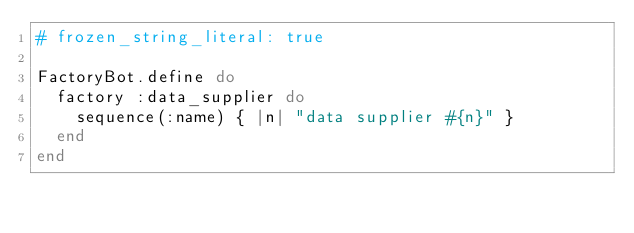<code> <loc_0><loc_0><loc_500><loc_500><_Ruby_># frozen_string_literal: true

FactoryBot.define do
  factory :data_supplier do
    sequence(:name) { |n| "data supplier #{n}" }
  end
end
</code> 